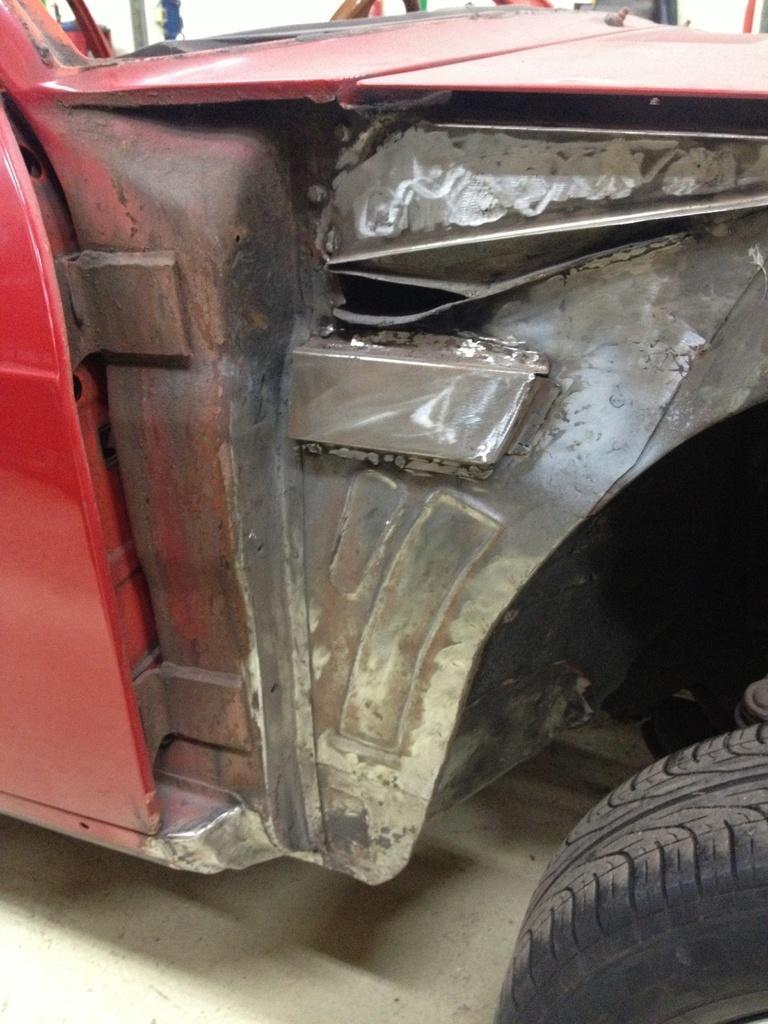How would you summarize this image in a sentence or two? In this picture I can observe red color vehicle. On the bottom right side there is a tyre. 